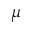Convert formula to latex. <formula><loc_0><loc_0><loc_500><loc_500>\mu</formula> 